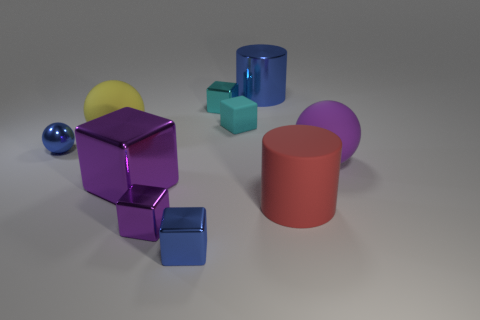How many small things are cyan metallic objects or cyan objects?
Offer a terse response. 2. What color is the cylinder that is behind the large ball right of the big matte ball that is left of the blue metal cube?
Ensure brevity in your answer.  Blue. What number of other objects are the same color as the small sphere?
Your response must be concise. 2. What number of rubber objects are tiny cyan objects or red things?
Your answer should be very brief. 2. Does the ball that is to the right of the red object have the same color as the big metal object that is to the left of the small purple shiny block?
Offer a terse response. Yes. What size is the blue metal thing that is the same shape as the tiny cyan matte thing?
Provide a succinct answer. Small. Is the number of big purple shiny cubes behind the tiny purple cube greater than the number of large green shiny things?
Provide a short and direct response. Yes. Is the material of the cylinder that is behind the cyan metallic cube the same as the small purple object?
Offer a terse response. Yes. There is a block that is on the right side of the cyan thing behind the cyan thing that is on the right side of the cyan metal object; what size is it?
Offer a terse response. Small. What size is the cylinder that is made of the same material as the large purple block?
Make the answer very short. Large. 